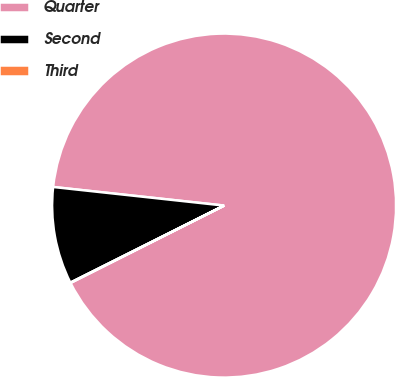Convert chart to OTSL. <chart><loc_0><loc_0><loc_500><loc_500><pie_chart><fcel>Quarter<fcel>Second<fcel>Third<nl><fcel>90.85%<fcel>9.12%<fcel>0.03%<nl></chart> 